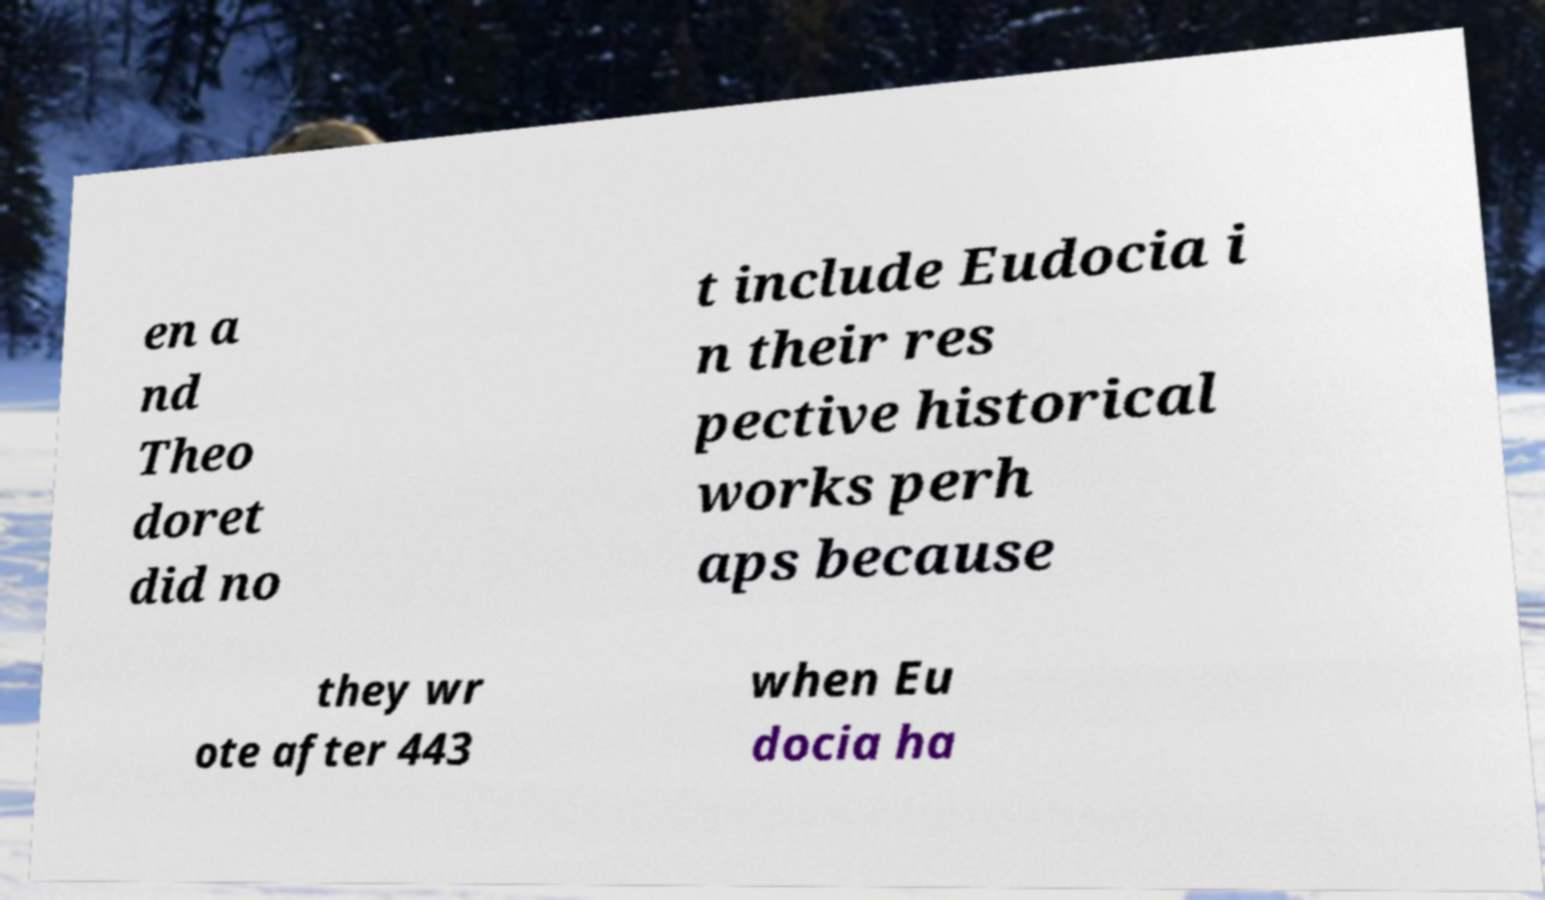Please read and relay the text visible in this image. What does it say? en a nd Theo doret did no t include Eudocia i n their res pective historical works perh aps because they wr ote after 443 when Eu docia ha 